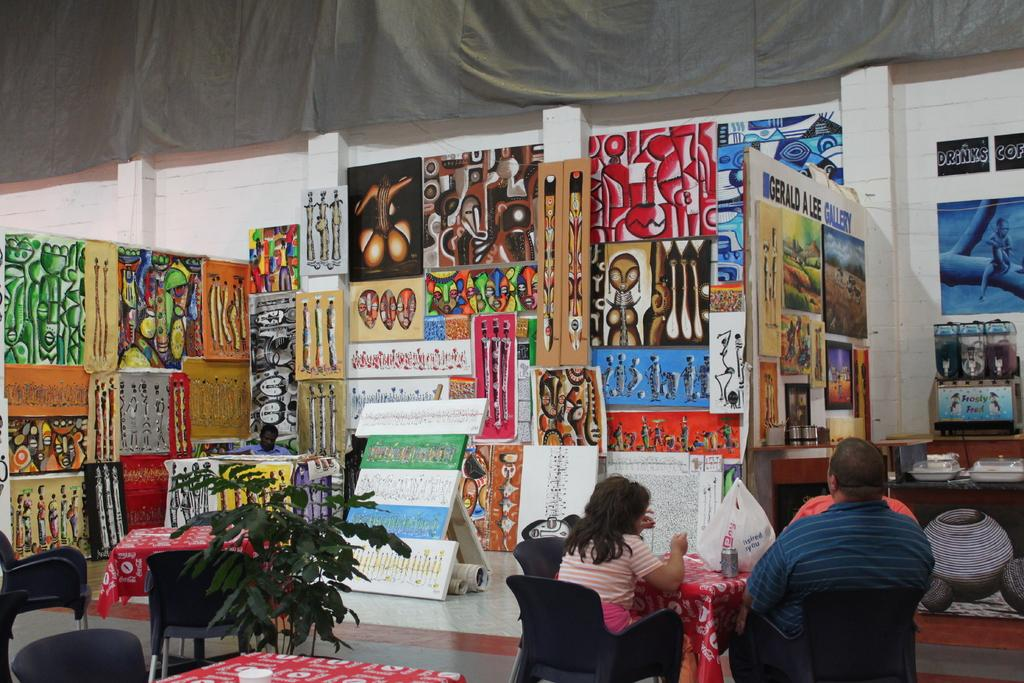What can be seen in the room in the image? There are many frames in the room. How many people are sitting around the table? There are three persons sitting around a table. What are the persons sitting on? The persons are seated on chairs. Are there any plants in the room? Yes, there are house plants in the room. Can you tell me how many firemen are present in the image? There is no fireman present in the image; it features three persons sitting around a table. What type of animal can be seen grazing in the room? There is no animal, such as a yak, present in the image; it features house plants in the room. 